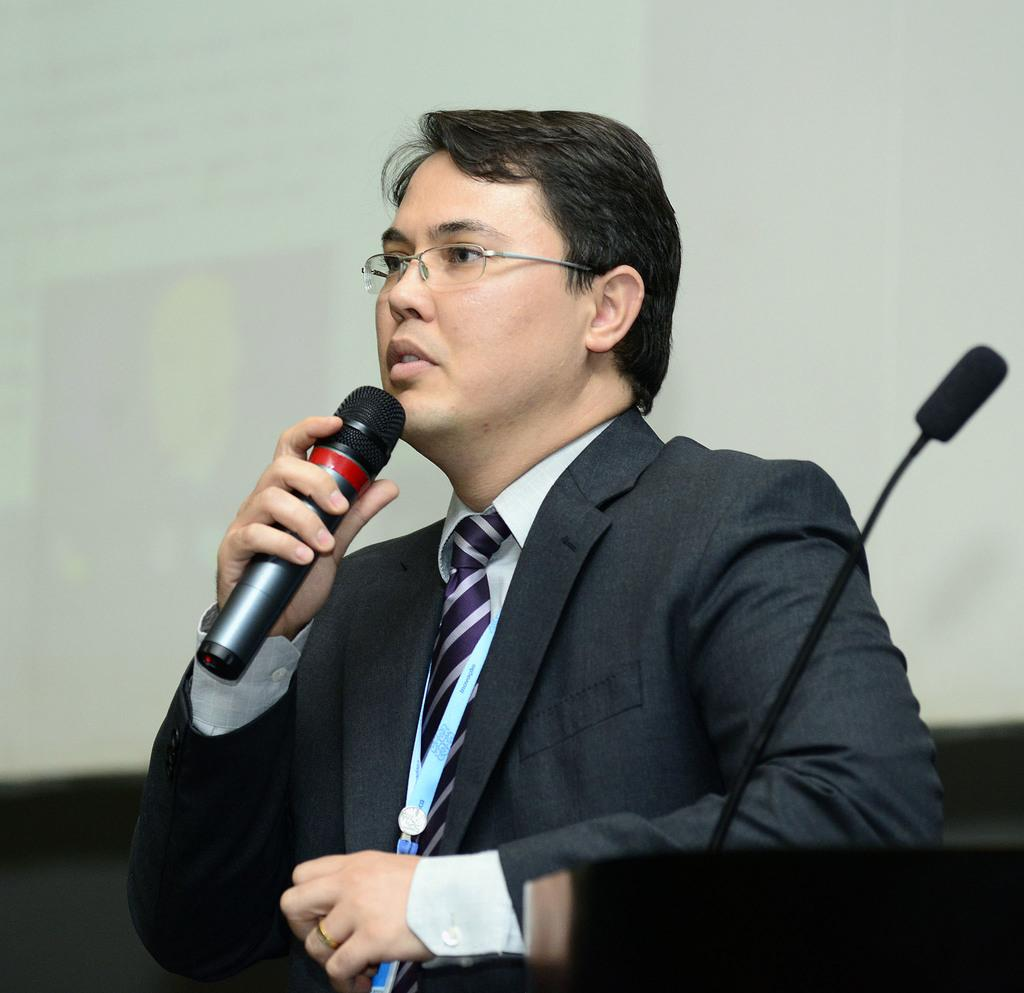Who is the main subject in the image? There is a man in the image. What is the man doing in the image? The man is talking on a mic. Where is the microphone located in relation to the man? The microphone is on the right side of the man. What can be seen behind the man in the image? There is a screen behind the man. How many brothers does the man have, and what are their names? There is no information about the man's brothers in the image, so we cannot determine their names or number. 